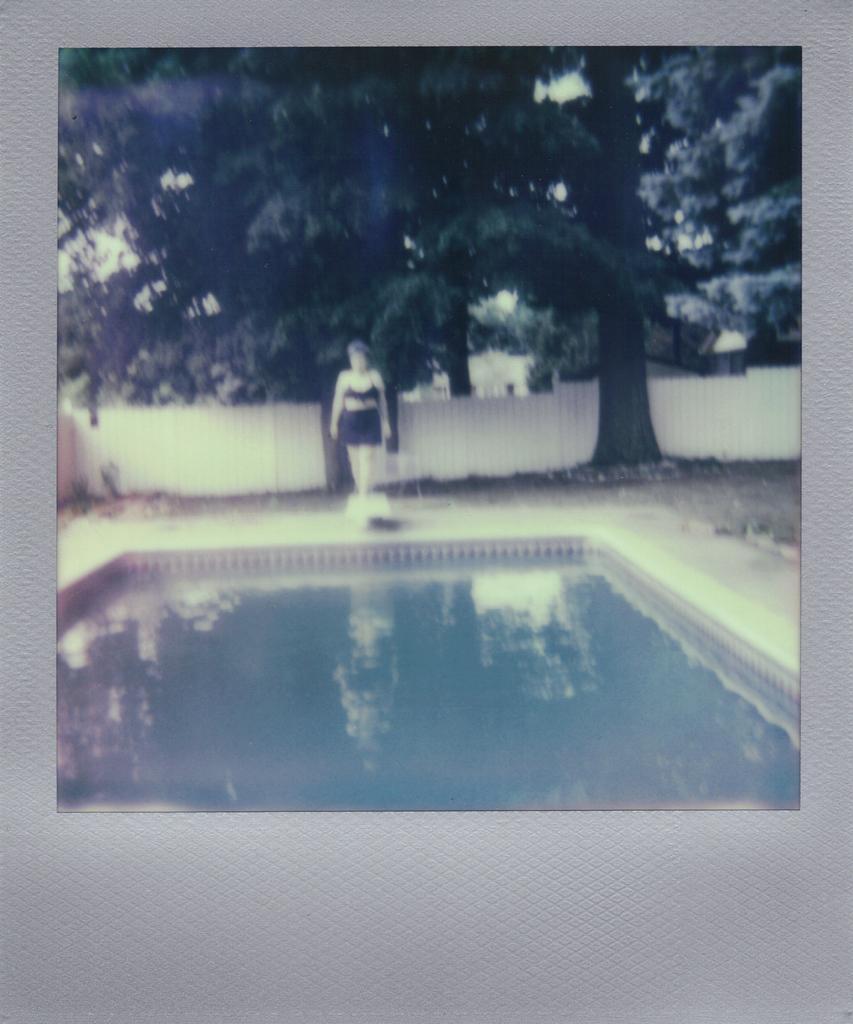Could you give a brief overview of what you see in this image? In this image we can see a swimming pool, lady wearing a black color dress. In the background of the image there are trees. There is a white color fencing. 